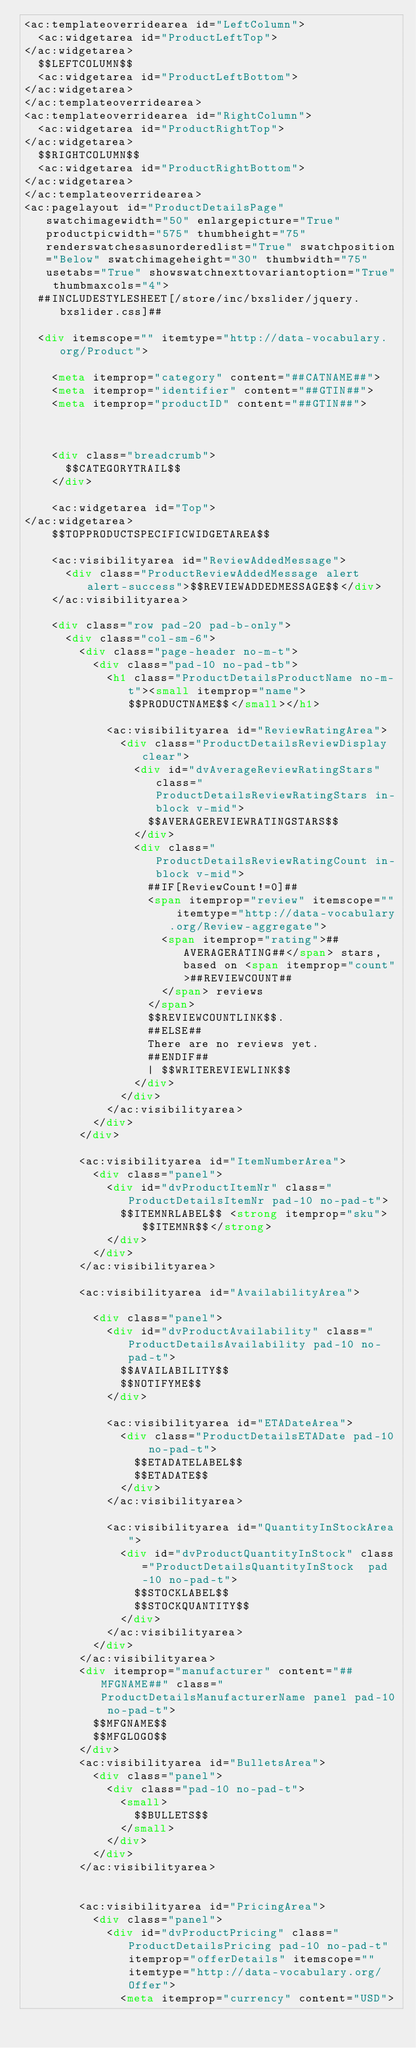<code> <loc_0><loc_0><loc_500><loc_500><_HTML_><ac:templateoverridearea id="LeftColumn">
  <ac:widgetarea id="ProductLeftTop">
</ac:widgetarea>
  $$LEFTCOLUMN$$
  <ac:widgetarea id="ProductLeftBottom">
</ac:widgetarea>
</ac:templateoverridearea>
<ac:templateoverridearea id="RightColumn">
  <ac:widgetarea id="ProductRightTop">
</ac:widgetarea>
  $$RIGHTCOLUMN$$
  <ac:widgetarea id="ProductRightBottom">
</ac:widgetarea>
</ac:templateoverridearea>
<ac:pagelayout id="ProductDetailsPage" swatchimagewidth="50" enlargepicture="True" productpicwidth="575" thumbheight="75" renderswatchesasunorderedlist="True" swatchposition="Below" swatchimageheight="30" thumbwidth="75" usetabs="True" showswatchnexttovariantoption="True" thumbmaxcols="4">
  ##INCLUDESTYLESHEET[/store/inc/bxslider/jquery.bxslider.css]##
  
  <div itemscope="" itemtype="http://data-vocabulary.org/Product">
    
    <meta itemprop="category" content="##CATNAME##">
    <meta itemprop="identifier" content="##GTIN##">
    <meta itemprop="productID" content="##GTIN##">
    
    
    
    <div class="breadcrumb">
      $$CATEGORYTRAIL$$
    </div>
    
    <ac:widgetarea id="Top">
</ac:widgetarea>
    $$TOPPRODUCTSPECIFICWIDGETAREA$$
    
    <ac:visibilityarea id="ReviewAddedMessage">
      <div class="ProductReviewAddedMessage alert alert-success">$$REVIEWADDEDMESSAGE$$</div>
    </ac:visibilityarea>
    
    <div class="row pad-20 pad-b-only">
      <div class="col-sm-6">
        <div class="page-header no-m-t">
          <div class="pad-10 no-pad-tb">
            <h1 class="ProductDetailsProductName no-m-t"><small itemprop="name">$$PRODUCTNAME$$</small></h1>
            
            <ac:visibilityarea id="ReviewRatingArea">
              <div class="ProductDetailsReviewDisplay clear">
                <div id="dvAverageReviewRatingStars" class="ProductDetailsReviewRatingStars in-block v-mid">
                  $$AVERAGEREVIEWRATINGSTARS$$
                </div>
                <div class="ProductDetailsReviewRatingCount in-block v-mid">
                  ##IF[ReviewCount!=0]##
                  <span itemprop="review" itemscope="" itemtype="http://data-vocabulary.org/Review-aggregate">
                    <span itemprop="rating">##AVERAGERATING##</span> stars, based on <span itemprop="count">##REVIEWCOUNT##
                    </span> reviews
                  </span>
                  $$REVIEWCOUNTLINK$$.
                  ##ELSE##
                  There are no reviews yet.
                  ##ENDIF##
                  | $$WRITEREVIEWLINK$$
                </div>
              </div>
            </ac:visibilityarea>
          </div>
        </div>
        
        <ac:visibilityarea id="ItemNumberArea">
          <div class="panel">
            <div id="dvProductItemNr" class="ProductDetailsItemNr pad-10 no-pad-t">
              $$ITEMNRLABEL$$ <strong itemprop="sku">$$ITEMNR$$</strong>
            </div>
          </div>
        </ac:visibilityarea>
        
        <ac:visibilityarea id="AvailabilityArea">
          
          <div class="panel">
            <div id="dvProductAvailability" class="ProductDetailsAvailability pad-10 no-pad-t">
              $$AVAILABILITY$$
              $$NOTIFYME$$
            </div>
            
            <ac:visibilityarea id="ETADateArea">
              <div class="ProductDetailsETADate pad-10 no-pad-t">
                $$ETADATELABEL$$
                $$ETADATE$$
              </div>
            </ac:visibilityarea>
            
            <ac:visibilityarea id="QuantityInStockArea">
              <div id="dvProductQuantityInStock" class="ProductDetailsQuantityInStock  pad-10 no-pad-t">
                $$STOCKLABEL$$
                $$STOCKQUANTITY$$
              </div>
            </ac:visibilityarea>
          </div>
        </ac:visibilityarea>
        <div itemprop="manufacturer" content="##MFGNAME##" class="ProductDetailsManufacturerName panel pad-10 no-pad-t">
          $$MFGNAME$$
          $$MFGLOGO$$
        </div>
        <ac:visibilityarea id="BulletsArea">
          <div class="panel">
            <div class="pad-10 no-pad-t">
              <small>
                $$BULLETS$$
              </small>
            </div>
          </div>
        </ac:visibilityarea>
        
        
        <ac:visibilityarea id="PricingArea">
          <div class="panel">
            <div id="dvProductPricing" class="ProductDetailsPricing pad-10 no-pad-t" itemprop="offerDetails" itemscope="" itemtype="http://data-vocabulary.org/Offer">
              <meta itemprop="currency" content="USD"></code> 